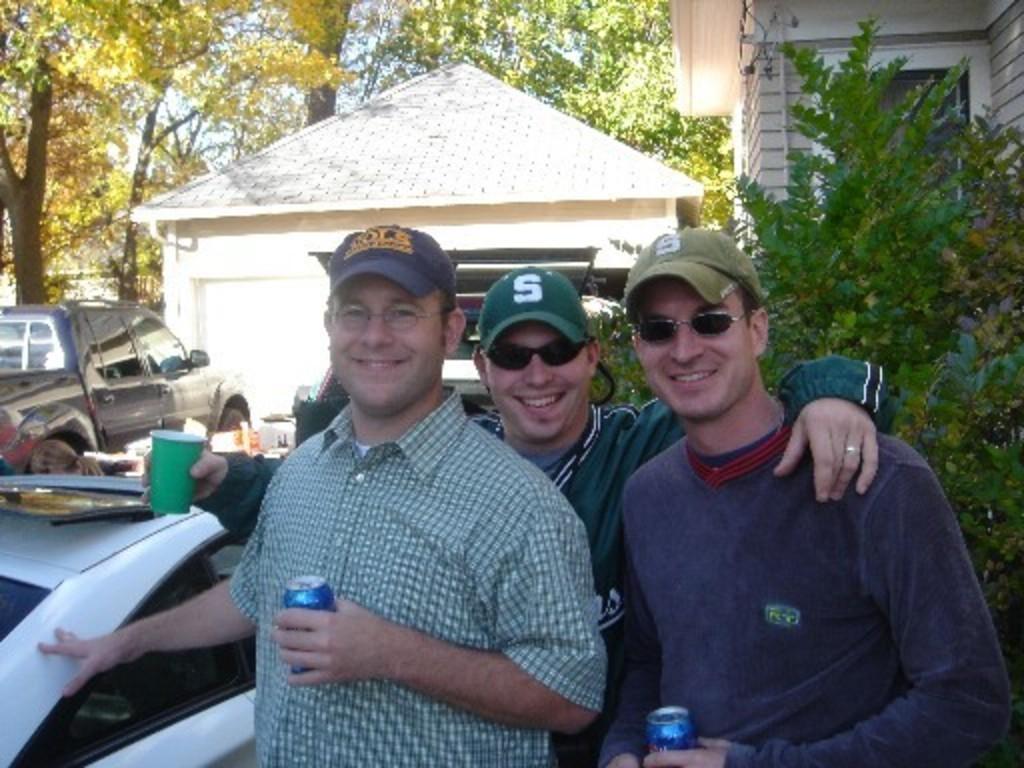Can you describe this image briefly? In this image there are persons truncated towards the bottom of the image, the persons are holding an object, there are trees truncated towards the top of the image, there is a tree truncated towards the right of the image, there are buildings, there is a building truncated towards the top of the image, there are vehicles truncated towards the left of the image. 